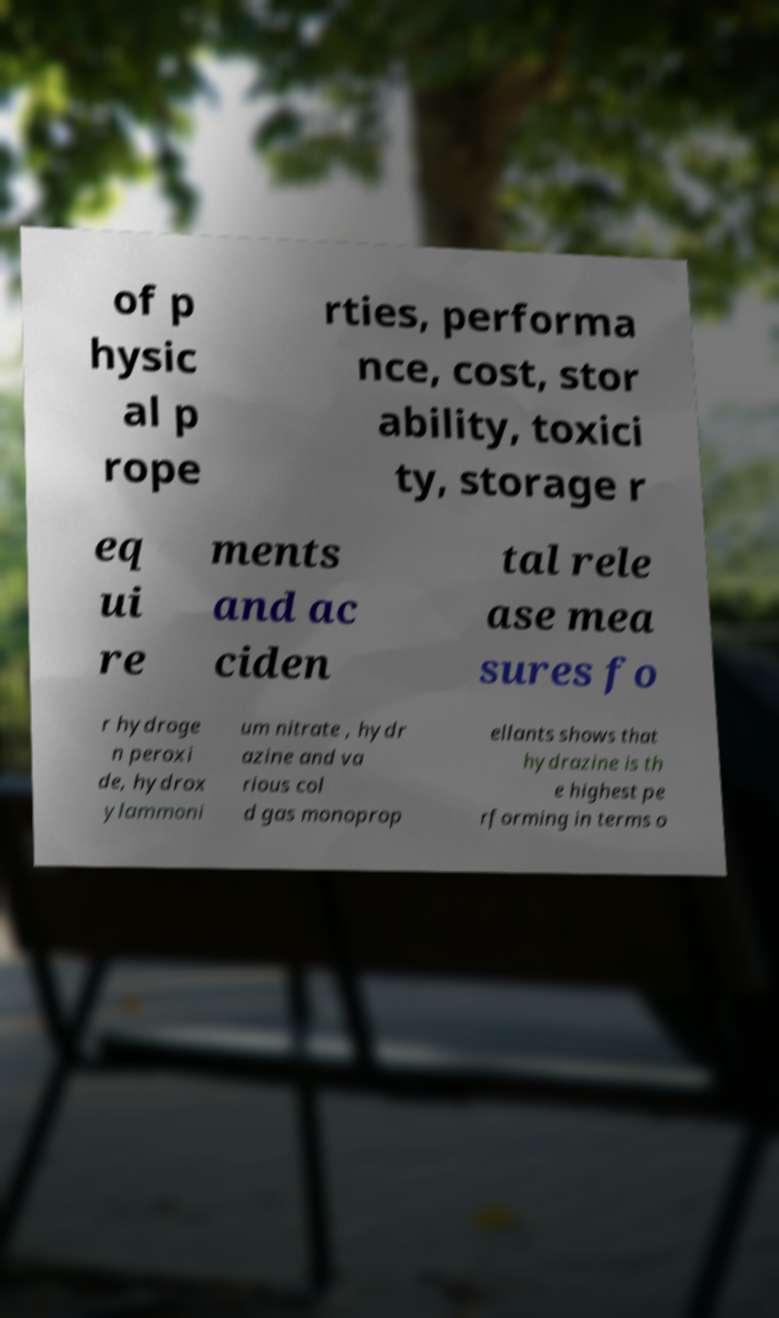There's text embedded in this image that I need extracted. Can you transcribe it verbatim? of p hysic al p rope rties, performa nce, cost, stor ability, toxici ty, storage r eq ui re ments and ac ciden tal rele ase mea sures fo r hydroge n peroxi de, hydrox ylammoni um nitrate , hydr azine and va rious col d gas monoprop ellants shows that hydrazine is th e highest pe rforming in terms o 